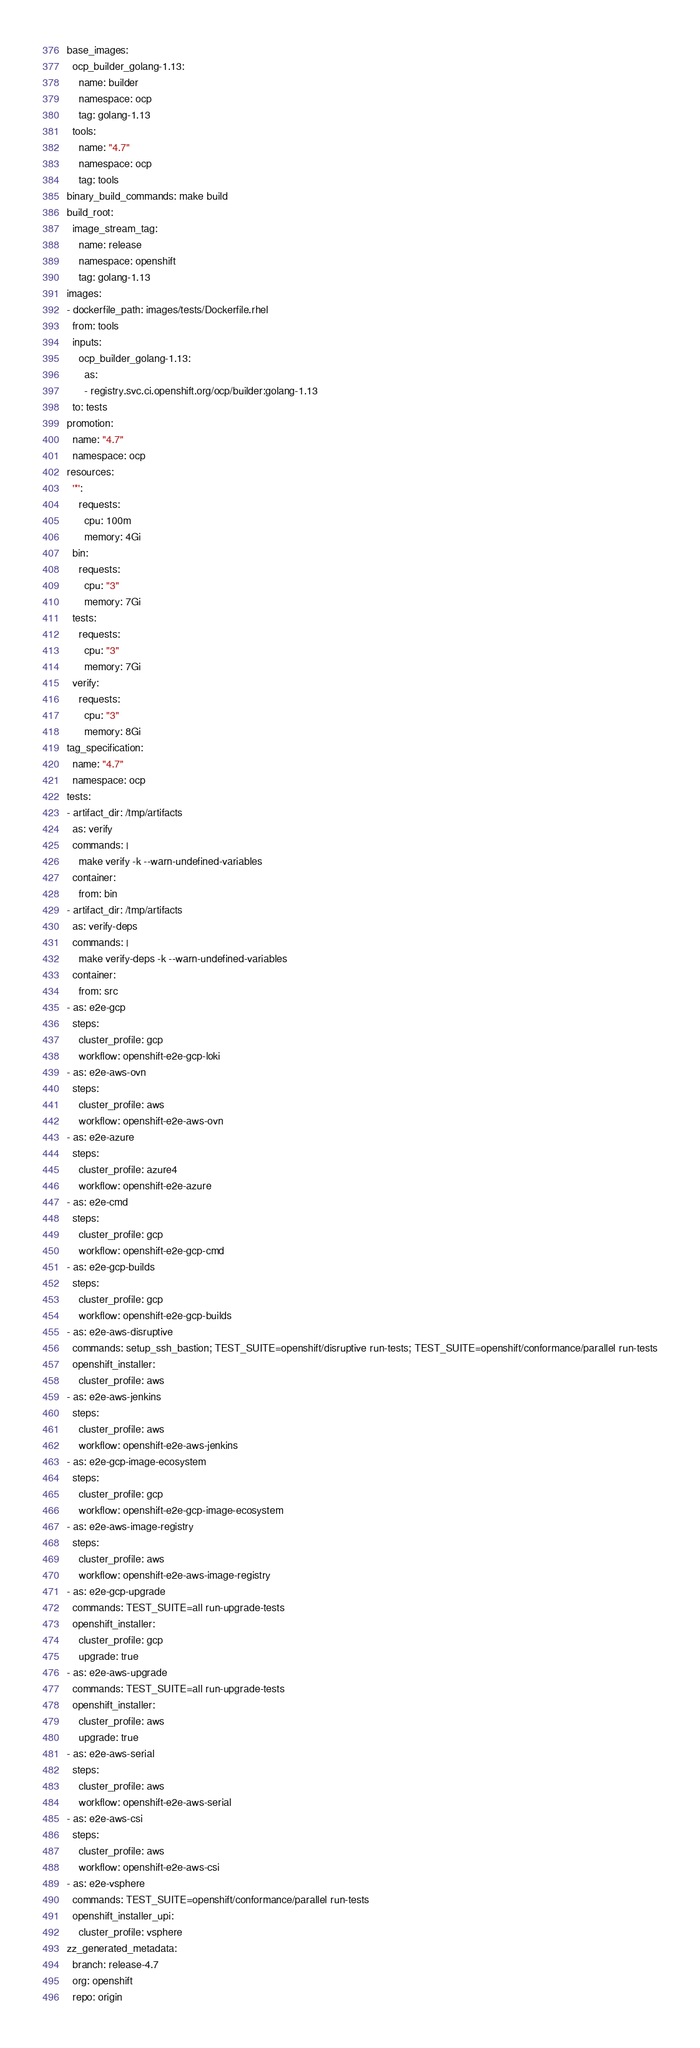Convert code to text. <code><loc_0><loc_0><loc_500><loc_500><_YAML_>base_images:
  ocp_builder_golang-1.13:
    name: builder
    namespace: ocp
    tag: golang-1.13
  tools:
    name: "4.7"
    namespace: ocp
    tag: tools
binary_build_commands: make build
build_root:
  image_stream_tag:
    name: release
    namespace: openshift
    tag: golang-1.13
images:
- dockerfile_path: images/tests/Dockerfile.rhel
  from: tools
  inputs:
    ocp_builder_golang-1.13:
      as:
      - registry.svc.ci.openshift.org/ocp/builder:golang-1.13
  to: tests
promotion:
  name: "4.7"
  namespace: ocp
resources:
  '*':
    requests:
      cpu: 100m
      memory: 4Gi
  bin:
    requests:
      cpu: "3"
      memory: 7Gi
  tests:
    requests:
      cpu: "3"
      memory: 7Gi
  verify:
    requests:
      cpu: "3"
      memory: 8Gi
tag_specification:
  name: "4.7"
  namespace: ocp
tests:
- artifact_dir: /tmp/artifacts
  as: verify
  commands: |
    make verify -k --warn-undefined-variables
  container:
    from: bin
- artifact_dir: /tmp/artifacts
  as: verify-deps
  commands: |
    make verify-deps -k --warn-undefined-variables
  container:
    from: src
- as: e2e-gcp
  steps:
    cluster_profile: gcp
    workflow: openshift-e2e-gcp-loki
- as: e2e-aws-ovn
  steps:
    cluster_profile: aws
    workflow: openshift-e2e-aws-ovn
- as: e2e-azure
  steps:
    cluster_profile: azure4
    workflow: openshift-e2e-azure
- as: e2e-cmd
  steps:
    cluster_profile: gcp
    workflow: openshift-e2e-gcp-cmd
- as: e2e-gcp-builds
  steps:
    cluster_profile: gcp
    workflow: openshift-e2e-gcp-builds
- as: e2e-aws-disruptive
  commands: setup_ssh_bastion; TEST_SUITE=openshift/disruptive run-tests; TEST_SUITE=openshift/conformance/parallel run-tests
  openshift_installer:
    cluster_profile: aws
- as: e2e-aws-jenkins
  steps:
    cluster_profile: aws
    workflow: openshift-e2e-aws-jenkins
- as: e2e-gcp-image-ecosystem
  steps:
    cluster_profile: gcp
    workflow: openshift-e2e-gcp-image-ecosystem
- as: e2e-aws-image-registry
  steps:
    cluster_profile: aws
    workflow: openshift-e2e-aws-image-registry
- as: e2e-gcp-upgrade
  commands: TEST_SUITE=all run-upgrade-tests
  openshift_installer:
    cluster_profile: gcp
    upgrade: true
- as: e2e-aws-upgrade
  commands: TEST_SUITE=all run-upgrade-tests
  openshift_installer:
    cluster_profile: aws
    upgrade: true
- as: e2e-aws-serial
  steps:
    cluster_profile: aws
    workflow: openshift-e2e-aws-serial
- as: e2e-aws-csi
  steps:
    cluster_profile: aws
    workflow: openshift-e2e-aws-csi
- as: e2e-vsphere
  commands: TEST_SUITE=openshift/conformance/parallel run-tests
  openshift_installer_upi:
    cluster_profile: vsphere
zz_generated_metadata:
  branch: release-4.7
  org: openshift
  repo: origin
</code> 